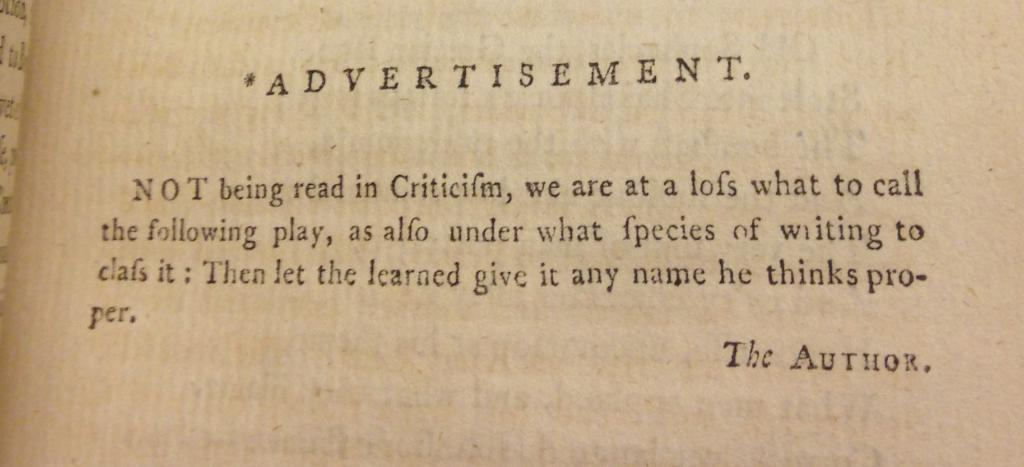Provide a one-sentence caption for the provided image. An advertisement to encourage people to see a new play. 